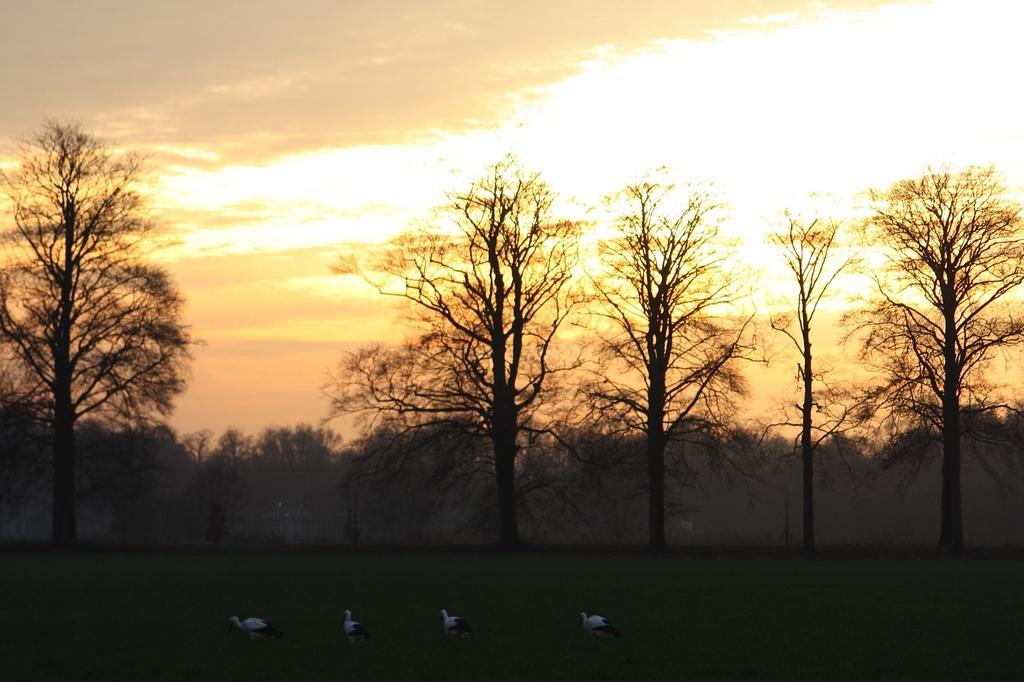Please provide a concise description of this image. In this picture there are birds and the birds are in black and white color. At the back there are trees. At the top there is sky and there are clouds and there is sun light. At the bottom there is grass. 